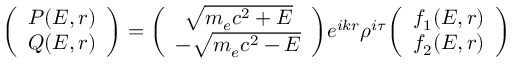Convert formula to latex. <formula><loc_0><loc_0><loc_500><loc_500>\left ( \begin{array} { c c } { P ( E , r ) } \\ { Q ( E , r ) } \end{array} \right ) = \left ( \begin{array} { c c } { \sqrt { m _ { e } c ^ { 2 } + E } } \\ { - \sqrt { m _ { e } c ^ { 2 } - E } } \end{array} \right ) e ^ { i k r } \rho ^ { i \tau } \left ( \begin{array} { c c } { f _ { 1 } ( E , r ) } \\ { f _ { 2 } ( E , r ) } \end{array} \right )</formula> 